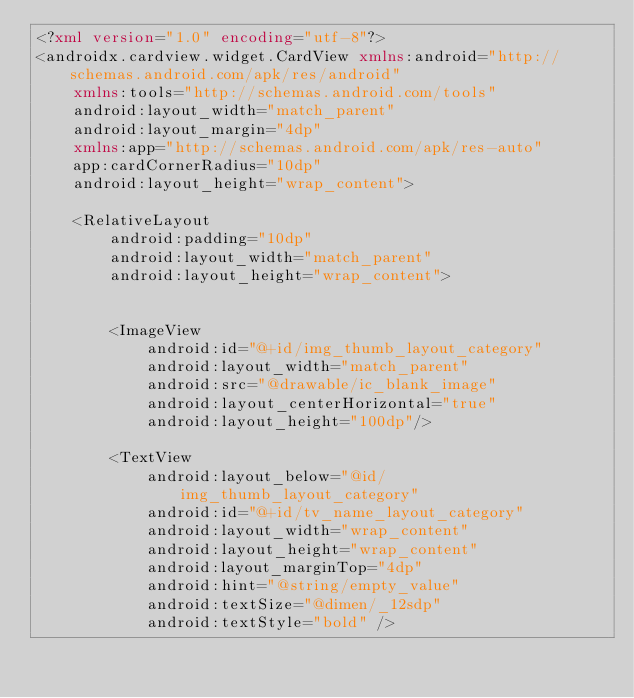Convert code to text. <code><loc_0><loc_0><loc_500><loc_500><_XML_><?xml version="1.0" encoding="utf-8"?>
<androidx.cardview.widget.CardView xmlns:android="http://schemas.android.com/apk/res/android"
    xmlns:tools="http://schemas.android.com/tools"
    android:layout_width="match_parent"
    android:layout_margin="4dp"
    xmlns:app="http://schemas.android.com/apk/res-auto"
    app:cardCornerRadius="10dp"
    android:layout_height="wrap_content">

    <RelativeLayout
        android:padding="10dp"
        android:layout_width="match_parent"
        android:layout_height="wrap_content">


        <ImageView
            android:id="@+id/img_thumb_layout_category"
            android:layout_width="match_parent"
            android:src="@drawable/ic_blank_image"
            android:layout_centerHorizontal="true"
            android:layout_height="100dp"/>

        <TextView
            android:layout_below="@id/img_thumb_layout_category"
            android:id="@+id/tv_name_layout_category"
            android:layout_width="wrap_content"
            android:layout_height="wrap_content"
            android:layout_marginTop="4dp"
            android:hint="@string/empty_value"
            android:textSize="@dimen/_12sdp"
            android:textStyle="bold" />
</code> 